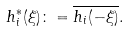Convert formula to latex. <formula><loc_0><loc_0><loc_500><loc_500>h _ { i } ^ { \ast } ( \xi ) \colon = \overline { h _ { i } ( - \xi ) } .</formula> 